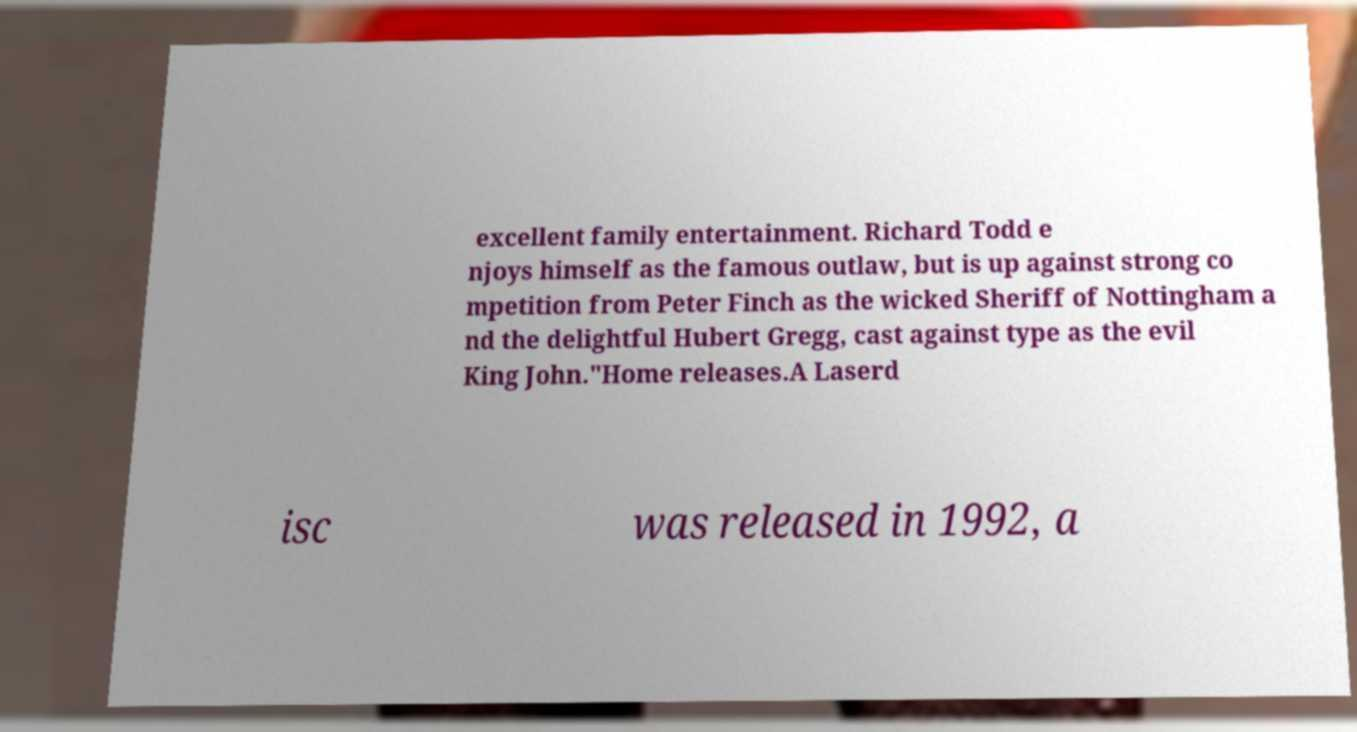Please read and relay the text visible in this image. What does it say? excellent family entertainment. Richard Todd e njoys himself as the famous outlaw, but is up against strong co mpetition from Peter Finch as the wicked Sheriff of Nottingham a nd the delightful Hubert Gregg, cast against type as the evil King John."Home releases.A Laserd isc was released in 1992, a 